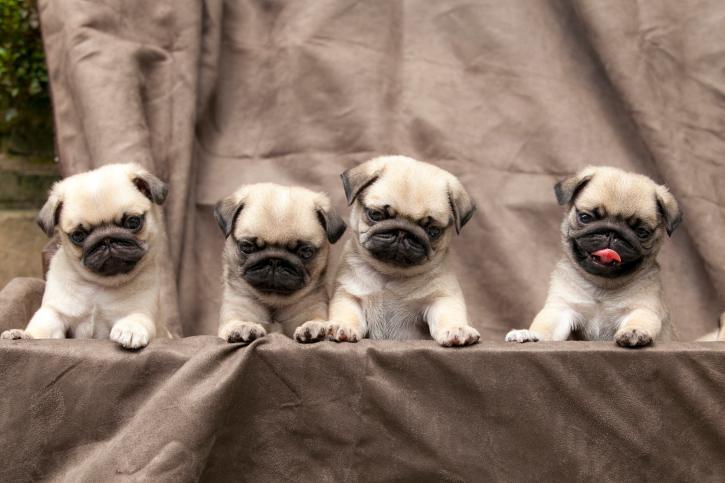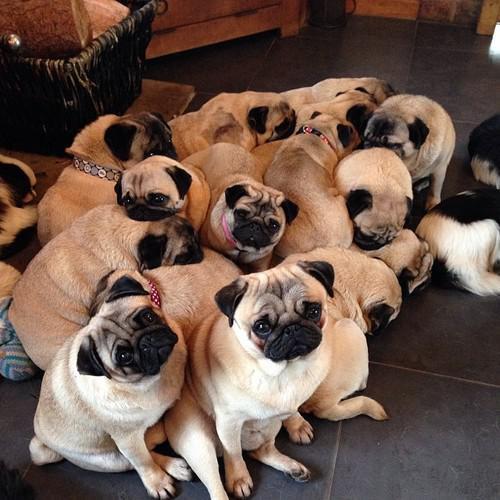The first image is the image on the left, the second image is the image on the right. Considering the images on both sides, is "There are less than 5 dogs in the left image." valid? Answer yes or no. Yes. 